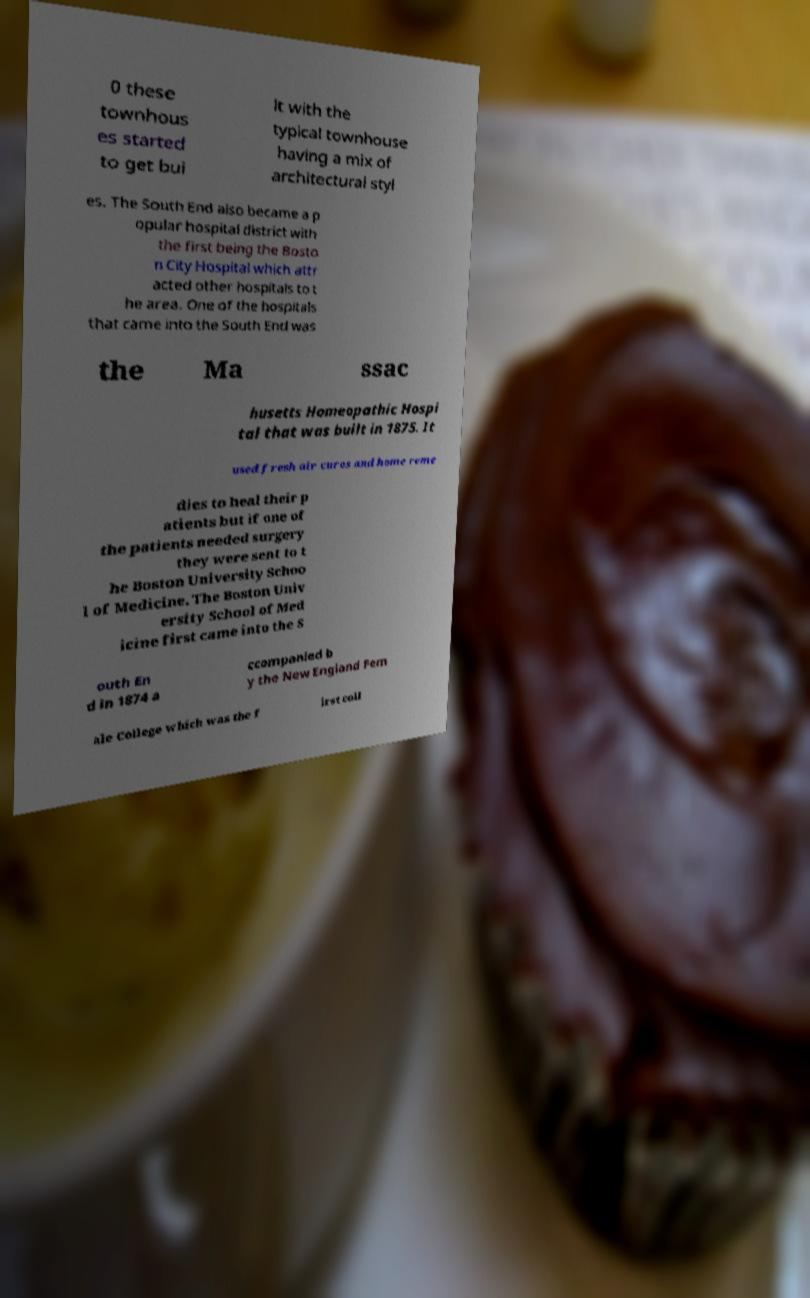Please read and relay the text visible in this image. What does it say? 0 these townhous es started to get bui lt with the typical townhouse having a mix of architectural styl es. The South End also became a p opular hospital district with the first being the Bosto n City Hospital which attr acted other hospitals to t he area. One of the hospitals that came into the South End was the Ma ssac husetts Homeopathic Hospi tal that was built in 1875. It used fresh air cures and home reme dies to heal their p atients but if one of the patients needed surgery they were sent to t he Boston University Schoo l of Medicine. The Boston Univ ersity School of Med icine first came into the S outh En d in 1874 a ccompanied b y the New England Fem ale College which was the f irst coll 